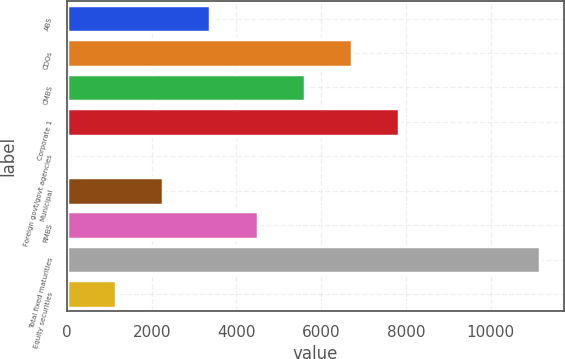Convert chart. <chart><loc_0><loc_0><loc_500><loc_500><bar_chart><fcel>ABS<fcel>CDOs<fcel>CMBS<fcel>Corporate 1<fcel>Foreign govt/govt agencies<fcel>Municipal<fcel>RMBS<fcel>Total fixed maturities<fcel>Equity securities<nl><fcel>3387.9<fcel>6724.8<fcel>5612.5<fcel>7837.1<fcel>51<fcel>2275.6<fcel>4500.2<fcel>11174<fcel>1163.3<nl></chart> 